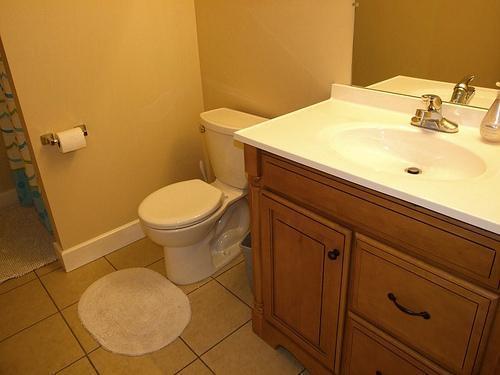How many rolls of toilet paper are there?
Give a very brief answer. 1. 